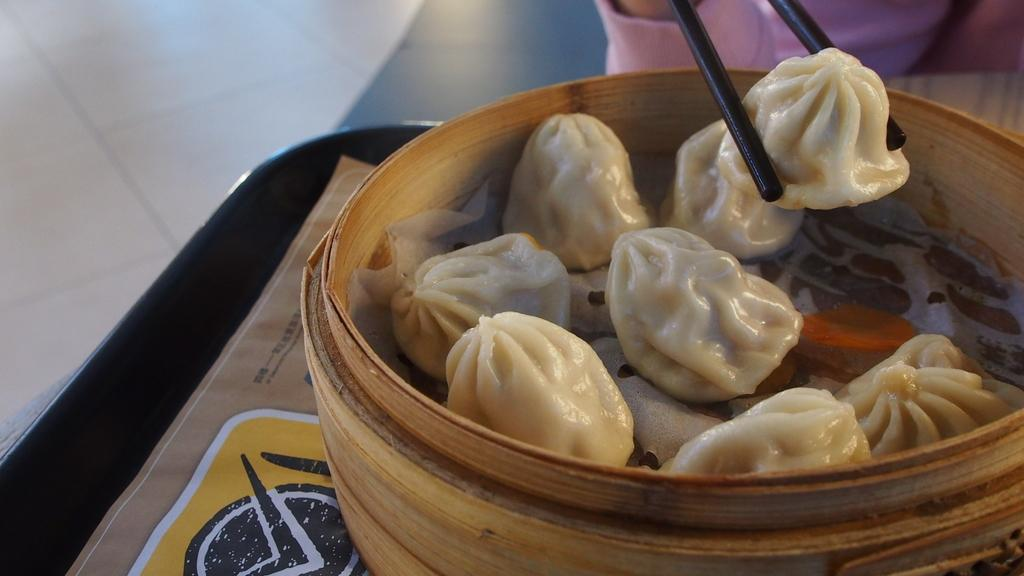What is present on the table in the image? There is a basket containing momos on the table. What is the person in the image holding? The person is holding chopsticks in the image. Where is the person located in the image? The person is on the right side of the image. What can be seen in the background of the image? There is a floor visible in the background of the image. What type of apparel is the stove wearing in the image? There is no stove present in the image, so it is not possible to determine what type of apparel it might be wearing. 